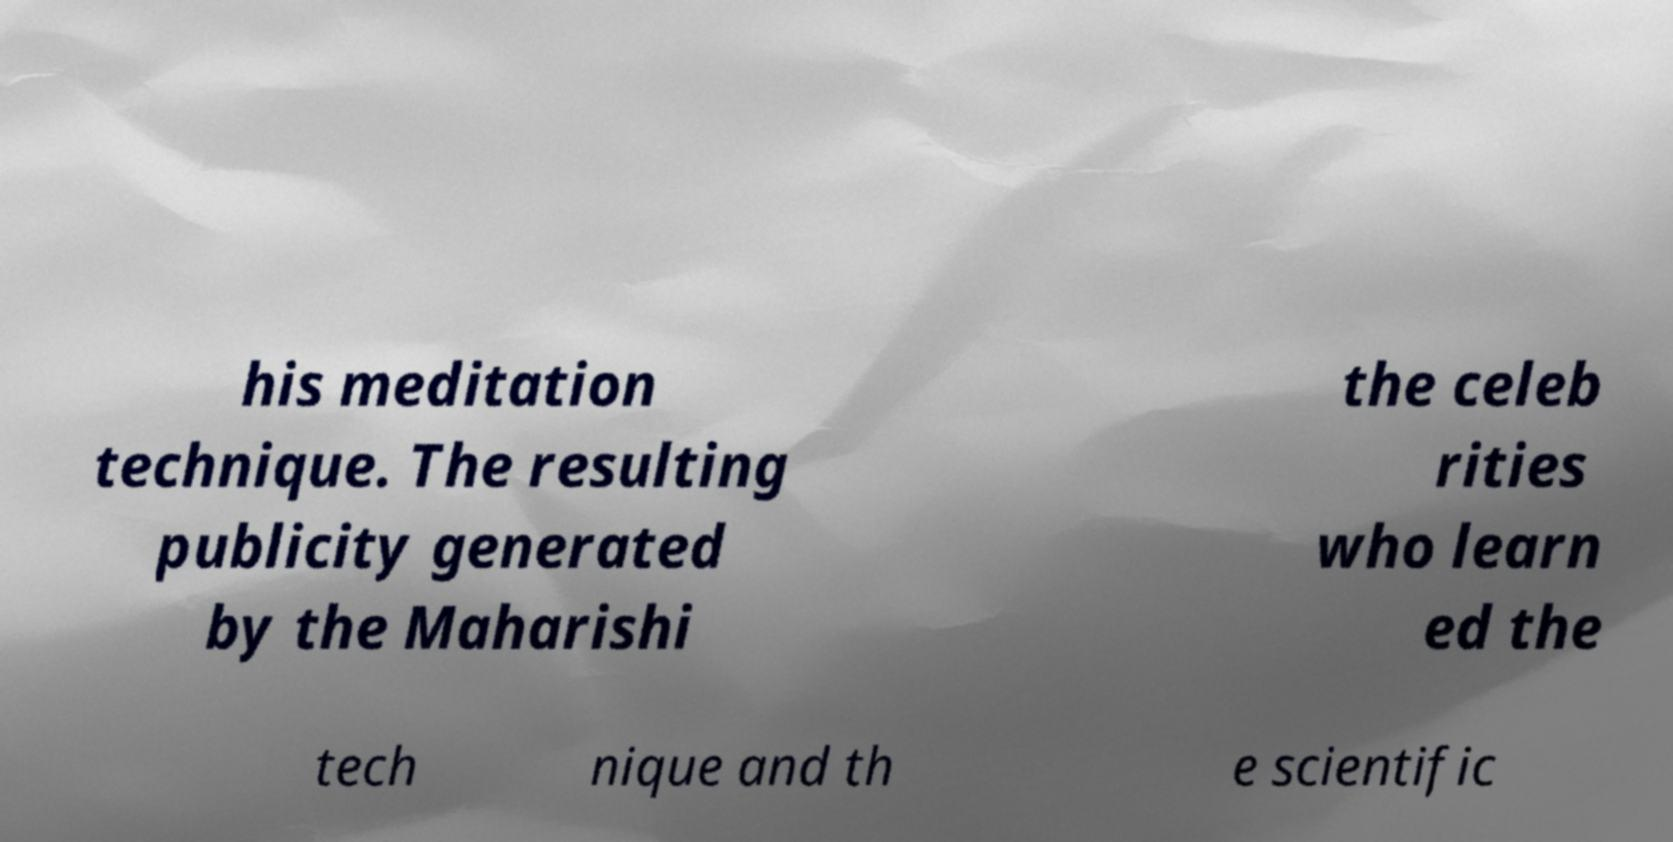For documentation purposes, I need the text within this image transcribed. Could you provide that? his meditation technique. The resulting publicity generated by the Maharishi the celeb rities who learn ed the tech nique and th e scientific 